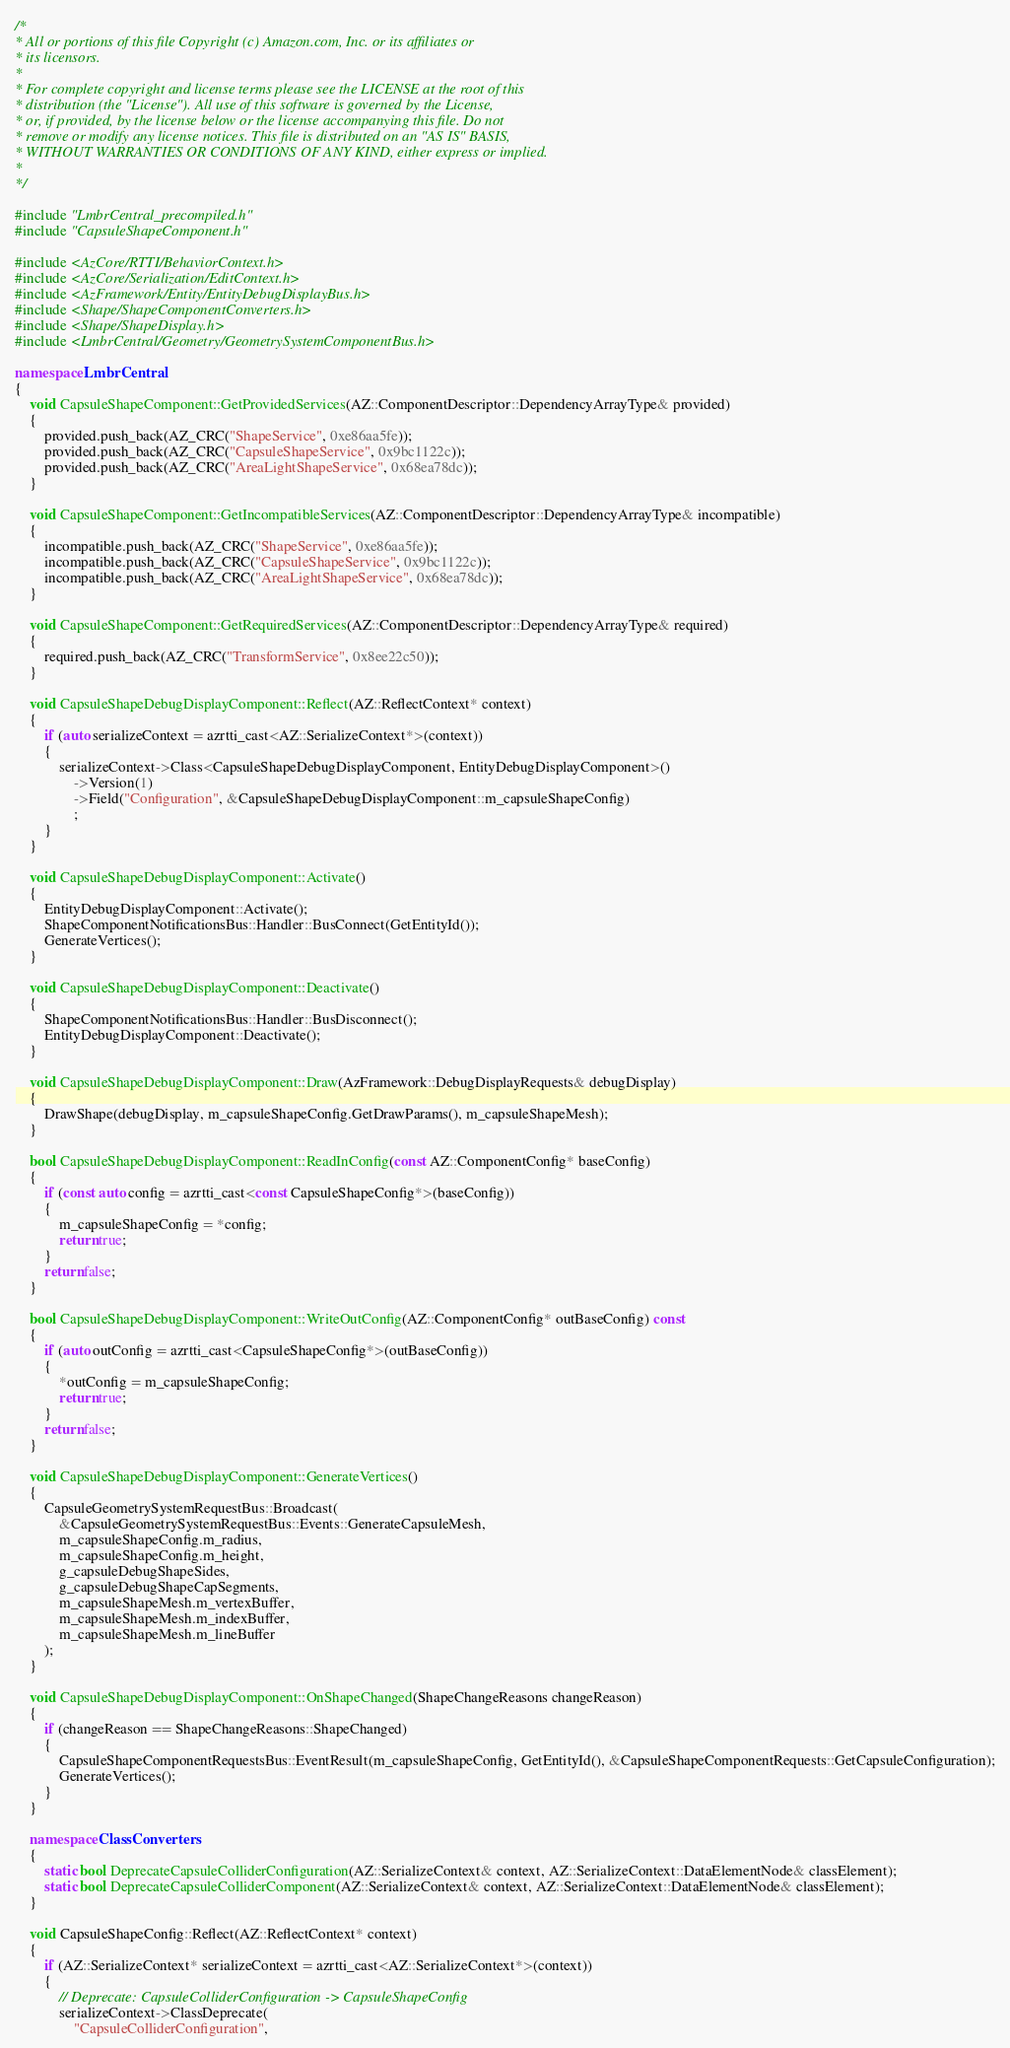<code> <loc_0><loc_0><loc_500><loc_500><_C++_>/*
* All or portions of this file Copyright (c) Amazon.com, Inc. or its affiliates or
* its licensors.
*
* For complete copyright and license terms please see the LICENSE at the root of this
* distribution (the "License"). All use of this software is governed by the License,
* or, if provided, by the license below or the license accompanying this file. Do not
* remove or modify any license notices. This file is distributed on an "AS IS" BASIS,
* WITHOUT WARRANTIES OR CONDITIONS OF ANY KIND, either express or implied.
*
*/

#include "LmbrCentral_precompiled.h"
#include "CapsuleShapeComponent.h"

#include <AzCore/RTTI/BehaviorContext.h>
#include <AzCore/Serialization/EditContext.h>
#include <AzFramework/Entity/EntityDebugDisplayBus.h>
#include <Shape/ShapeComponentConverters.h>
#include <Shape/ShapeDisplay.h>
#include <LmbrCentral/Geometry/GeometrySystemComponentBus.h>

namespace LmbrCentral
{
    void CapsuleShapeComponent::GetProvidedServices(AZ::ComponentDescriptor::DependencyArrayType& provided)
    {
        provided.push_back(AZ_CRC("ShapeService", 0xe86aa5fe));
        provided.push_back(AZ_CRC("CapsuleShapeService", 0x9bc1122c));
        provided.push_back(AZ_CRC("AreaLightShapeService", 0x68ea78dc));
    }

    void CapsuleShapeComponent::GetIncompatibleServices(AZ::ComponentDescriptor::DependencyArrayType& incompatible)
    {
        incompatible.push_back(AZ_CRC("ShapeService", 0xe86aa5fe));
        incompatible.push_back(AZ_CRC("CapsuleShapeService", 0x9bc1122c));
        incompatible.push_back(AZ_CRC("AreaLightShapeService", 0x68ea78dc));
    }

    void CapsuleShapeComponent::GetRequiredServices(AZ::ComponentDescriptor::DependencyArrayType& required)
    {
        required.push_back(AZ_CRC("TransformService", 0x8ee22c50));
    }

    void CapsuleShapeDebugDisplayComponent::Reflect(AZ::ReflectContext* context)
    {
        if (auto serializeContext = azrtti_cast<AZ::SerializeContext*>(context))
        {
            serializeContext->Class<CapsuleShapeDebugDisplayComponent, EntityDebugDisplayComponent>()
                ->Version(1)
                ->Field("Configuration", &CapsuleShapeDebugDisplayComponent::m_capsuleShapeConfig)
                ;
        }
    }

    void CapsuleShapeDebugDisplayComponent::Activate()
    {
        EntityDebugDisplayComponent::Activate();
        ShapeComponentNotificationsBus::Handler::BusConnect(GetEntityId());
        GenerateVertices();
    }

    void CapsuleShapeDebugDisplayComponent::Deactivate()
    {
        ShapeComponentNotificationsBus::Handler::BusDisconnect();
        EntityDebugDisplayComponent::Deactivate();
    }

    void CapsuleShapeDebugDisplayComponent::Draw(AzFramework::DebugDisplayRequests& debugDisplay)
    {
        DrawShape(debugDisplay, m_capsuleShapeConfig.GetDrawParams(), m_capsuleShapeMesh);
    }

    bool CapsuleShapeDebugDisplayComponent::ReadInConfig(const AZ::ComponentConfig* baseConfig)
    {
        if (const auto config = azrtti_cast<const CapsuleShapeConfig*>(baseConfig))
        {
            m_capsuleShapeConfig = *config;
            return true;
        }
        return false;
    }

    bool CapsuleShapeDebugDisplayComponent::WriteOutConfig(AZ::ComponentConfig* outBaseConfig) const
    {
        if (auto outConfig = azrtti_cast<CapsuleShapeConfig*>(outBaseConfig))
        {
            *outConfig = m_capsuleShapeConfig;
            return true;
        }
        return false;
    }

    void CapsuleShapeDebugDisplayComponent::GenerateVertices()
    {
        CapsuleGeometrySystemRequestBus::Broadcast(
            &CapsuleGeometrySystemRequestBus::Events::GenerateCapsuleMesh,
            m_capsuleShapeConfig.m_radius,
            m_capsuleShapeConfig.m_height,
            g_capsuleDebugShapeSides,
            g_capsuleDebugShapeCapSegments,
            m_capsuleShapeMesh.m_vertexBuffer,
            m_capsuleShapeMesh.m_indexBuffer,
            m_capsuleShapeMesh.m_lineBuffer
        );
    }

    void CapsuleShapeDebugDisplayComponent::OnShapeChanged(ShapeChangeReasons changeReason)
    {
        if (changeReason == ShapeChangeReasons::ShapeChanged)
        {
            CapsuleShapeComponentRequestsBus::EventResult(m_capsuleShapeConfig, GetEntityId(), &CapsuleShapeComponentRequests::GetCapsuleConfiguration);
            GenerateVertices();
        }
    }

    namespace ClassConverters
    {
        static bool DeprecateCapsuleColliderConfiguration(AZ::SerializeContext& context, AZ::SerializeContext::DataElementNode& classElement);
        static bool DeprecateCapsuleColliderComponent(AZ::SerializeContext& context, AZ::SerializeContext::DataElementNode& classElement);
    }

    void CapsuleShapeConfig::Reflect(AZ::ReflectContext* context)
    {
        if (AZ::SerializeContext* serializeContext = azrtti_cast<AZ::SerializeContext*>(context))
        {
            // Deprecate: CapsuleColliderConfiguration -> CapsuleShapeConfig
            serializeContext->ClassDeprecate(
                "CapsuleColliderConfiguration",</code> 